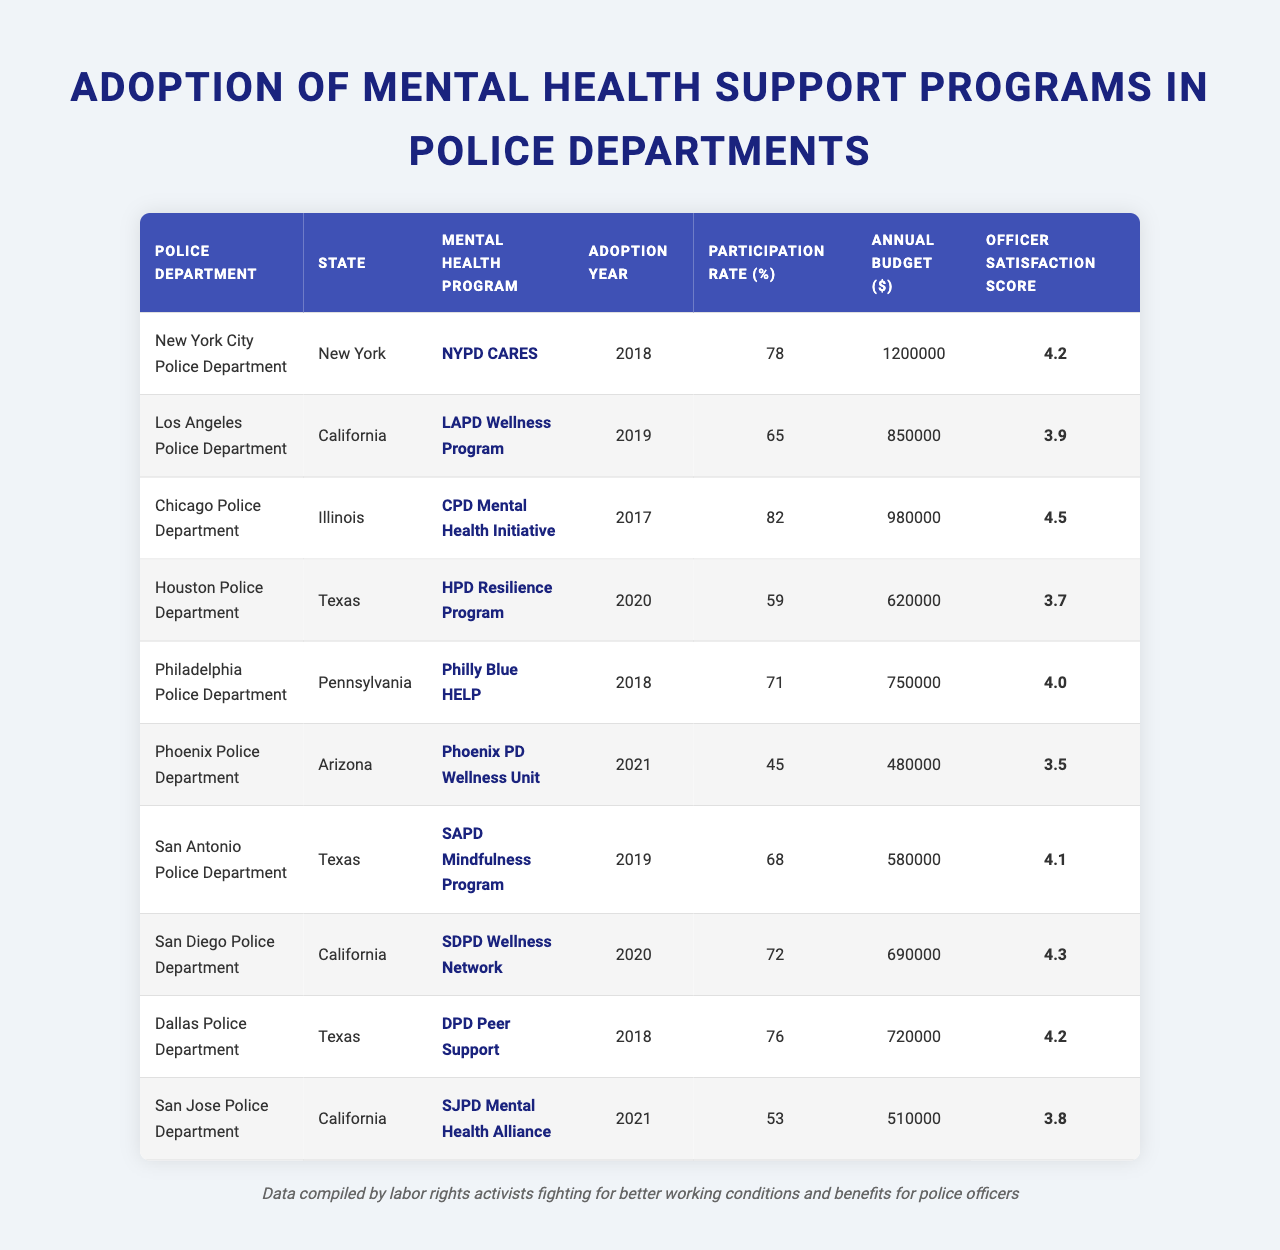What is the adoption year for the LAPD Wellness Program? The LAPD Wellness Program is listed in the table with its adoption year noted as 2019.
Answer: 2019 Which police department has the highest participation rate in their mental health program? By comparing the participation rates listed in the table, the Chicago Police Department has the highest rate at 82%.
Answer: 82% What is the annual budget for the San Antonio Police Department's Mindfulness Program? The table indicates that the annual budget for the SAPD Mindfulness Program is $580,000.
Answer: $580,000 Is the officer satisfaction score for the Houston Police Department higher than that of the Los Angeles Police Department? The officer satisfaction score for HPD is 3.7, while for LAPD it is 3.9, thus HPD's score is lower than LAPD's.
Answer: No What is the difference in participation rates between the New York City Police Department and the Phoenix Police Department? The participation rate for NYPD is 78%, and for Phoenix PD, it is 45%. The difference is 78 - 45 = 33%.
Answer: 33% What is the average officer satisfaction score across all listed police departments? Adding the officer satisfaction scores (4.2 + 3.9 + 4.5 + 3.7 + 4.0 + 3.5 + 4.1 + 4.3 + 4.2 + 3.8 = 43.2) and dividing by 10 gives an average score of 4.32.
Answer: 4.32 Which police department has the lowest annual budget for its mental health program? By reviewing the table's budget values, the Phoenix Police Department has the lowest budget at $480,000.
Answer: $480,000 Were both the New York City and Chicago Police Departments' programs adopted before 2020? NYPD CARES was adopted in 2018 and CPD Mental Health Initiative in 2017, so both were adopted before 2020.
Answer: Yes Which program has a higher participation rate, the DPD Peer Support or the HPD Resilience Program? DPD Peer Support has a participation rate of 76%, while HPD Resilience Program has 59%, making DPD's rate higher.
Answer: DPD Peer Support If the officer satisfaction scores were to be ranked, which police department would come in third place? Ranking the satisfaction scores in descending order: Chicago (4.5), NYPD (4.2), Dallas (4.2) is tied with NYPD, but comes next in the numeric order, thus, the ranking gives third place to Dallas.
Answer: Dallas Police Department 